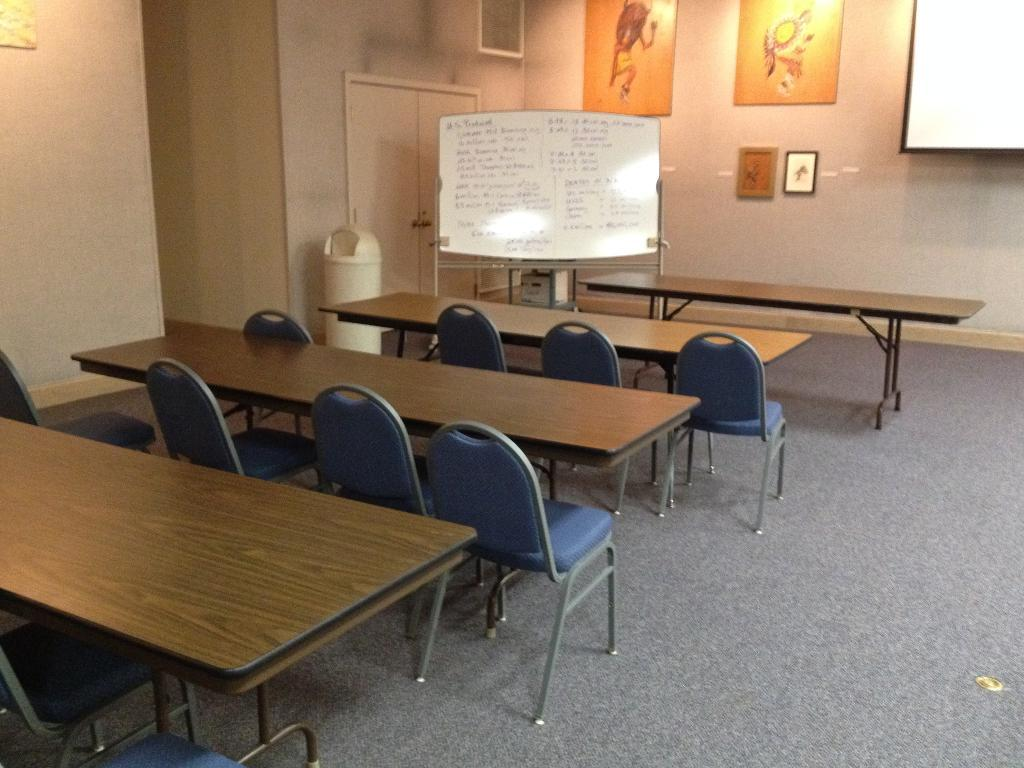What type of furniture is on the floor in the image? There are tables and chairs on the floor in the image. What can be seen in the background of the image? In the background, there is a wall, boards, photo frames, a dustbin, and doors. Can you describe the wall in the background? The wall is in the background, but no specific details about its appearance are provided in the facts. What type of bun is the dad holding in the image? There is no dad or bun present in the image. What type of exchange is taking place between the people in the image? There are no people or exchange taking place in the image; it only shows tables, chairs, and objects in the background. 